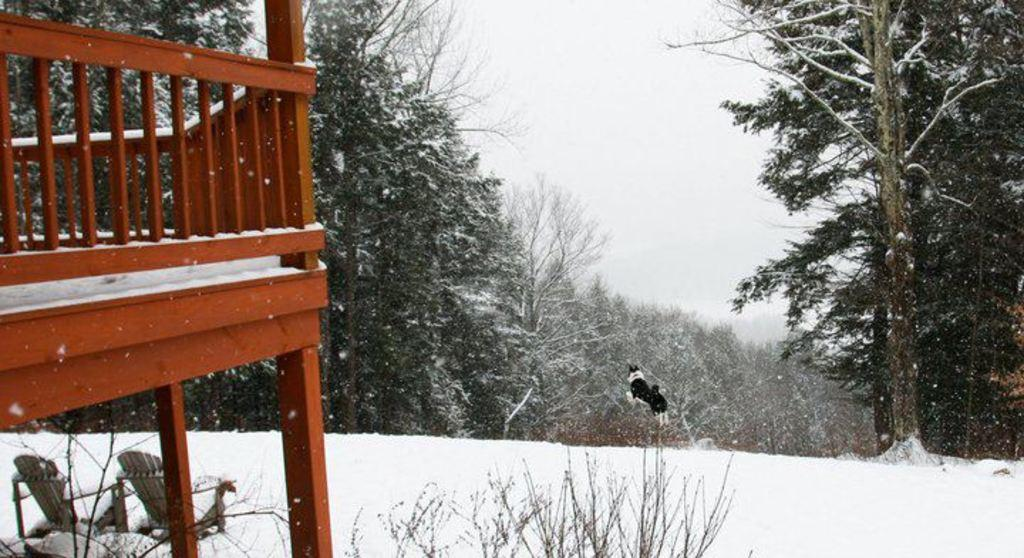What animal can be seen in the image? There is a dog in the image. What is the dog doing in the image? The dog is jumping in the air. What objects are on the left side of the image? There are chairs and a wooden fence on the left side of the image. What type of vegetation is present on the left side of the image? There are plants on the left side of the image. What can be seen in the background of the image? There are trees and the sky visible in the background of the image. What is covering the ground in the image? The ground is covered in snow. What type of milk is being poured into the representative's cup in the image? There is no representative or milk present in the image. 